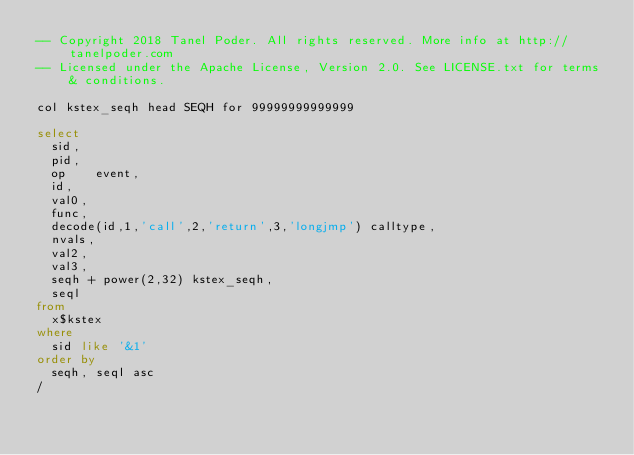Convert code to text. <code><loc_0><loc_0><loc_500><loc_500><_SQL_>-- Copyright 2018 Tanel Poder. All rights reserved. More info at http://tanelpoder.com
-- Licensed under the Apache License, Version 2.0. See LICENSE.txt for terms & conditions.

col kstex_seqh head SEQH for 99999999999999

select 
	sid,
	pid,
	op    event, 
	id,
	val0, 
	func, 
	decode(id,1,'call',2,'return',3,'longjmp') calltype, 
	nvals,  
	val2, 
	val3,
	seqh + power(2,32) kstex_seqh, 
	seql 
from 
	x$kstex 
where
	sid like '&1'
order by
	seqh, seql asc
/

</code> 